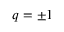Convert formula to latex. <formula><loc_0><loc_0><loc_500><loc_500>q = \pm 1</formula> 